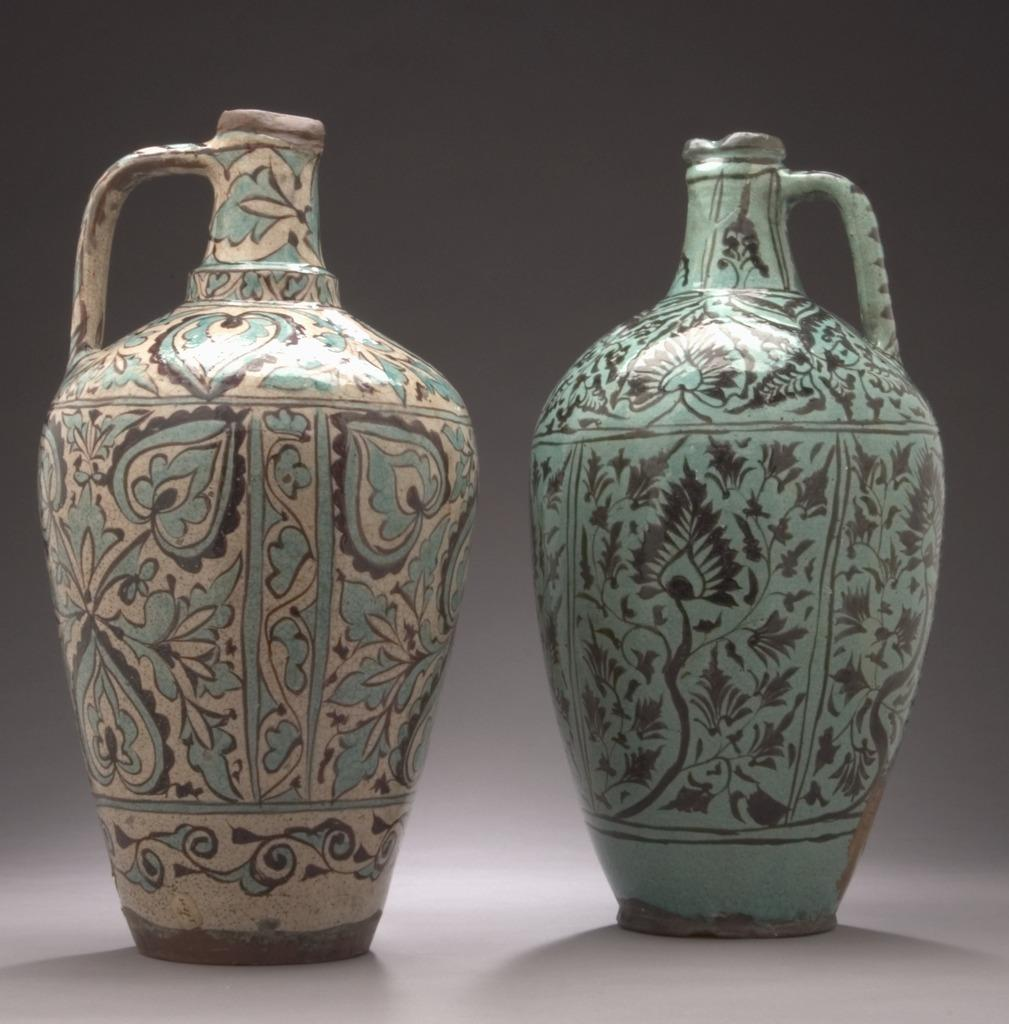How many pots can be seen in the image? There are two pots in the image. What is unique about the pots in the image? The pots have a painting on them. What type of oven is used to cook the elbow in the image? There is no oven or elbow present in the image; it features two pots with a painting on them. 